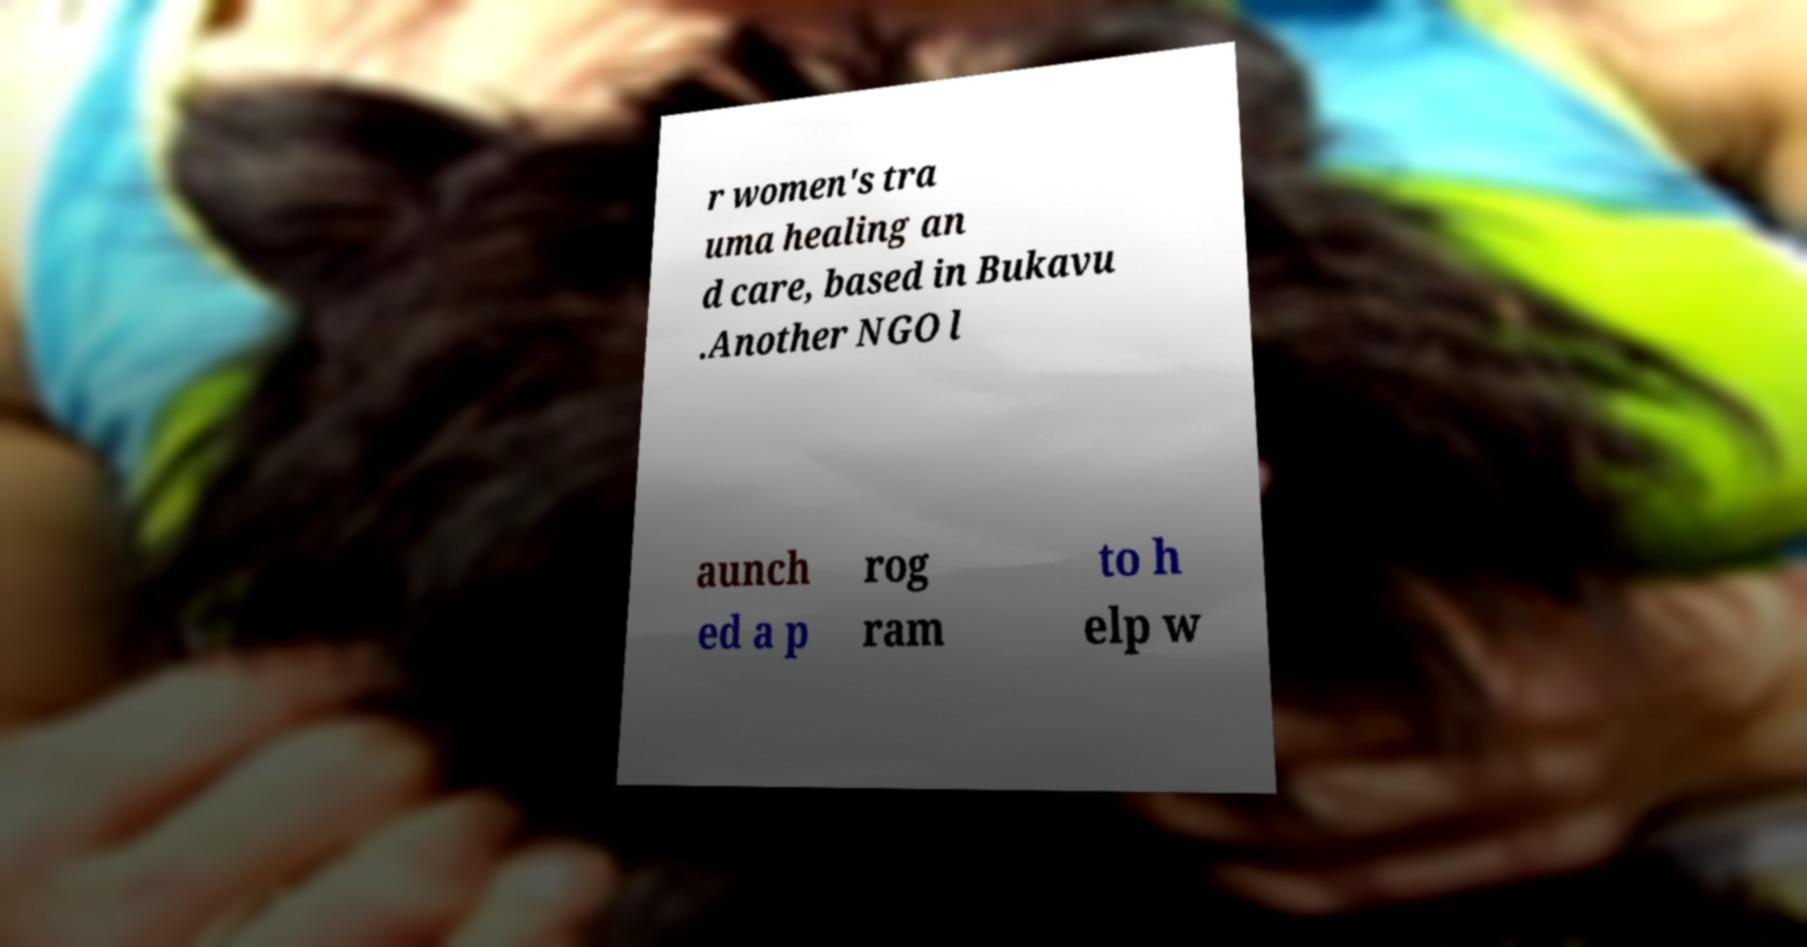For documentation purposes, I need the text within this image transcribed. Could you provide that? r women's tra uma healing an d care, based in Bukavu .Another NGO l aunch ed a p rog ram to h elp w 